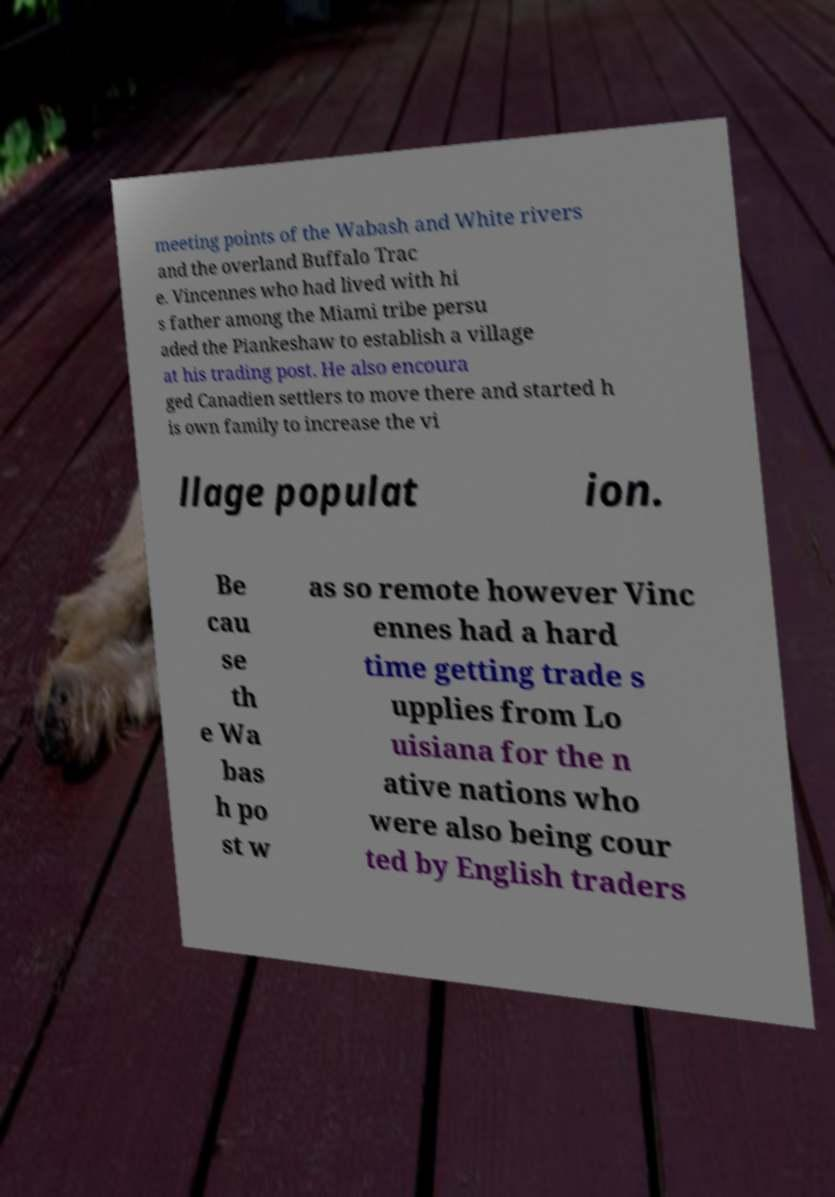Could you extract and type out the text from this image? meeting points of the Wabash and White rivers and the overland Buffalo Trac e. Vincennes who had lived with hi s father among the Miami tribe persu aded the Piankeshaw to establish a village at his trading post. He also encoura ged Canadien settlers to move there and started h is own family to increase the vi llage populat ion. Be cau se th e Wa bas h po st w as so remote however Vinc ennes had a hard time getting trade s upplies from Lo uisiana for the n ative nations who were also being cour ted by English traders 